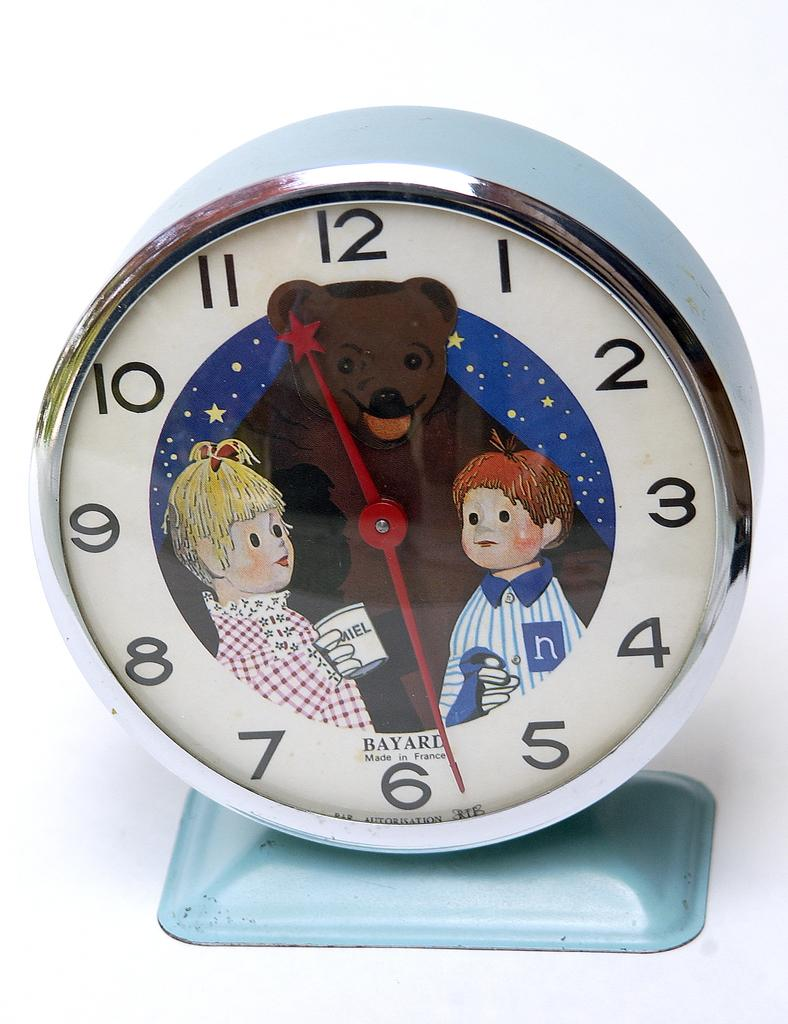<image>
Summarize the visual content of the image. A Bayard analog clock that was made in France. 